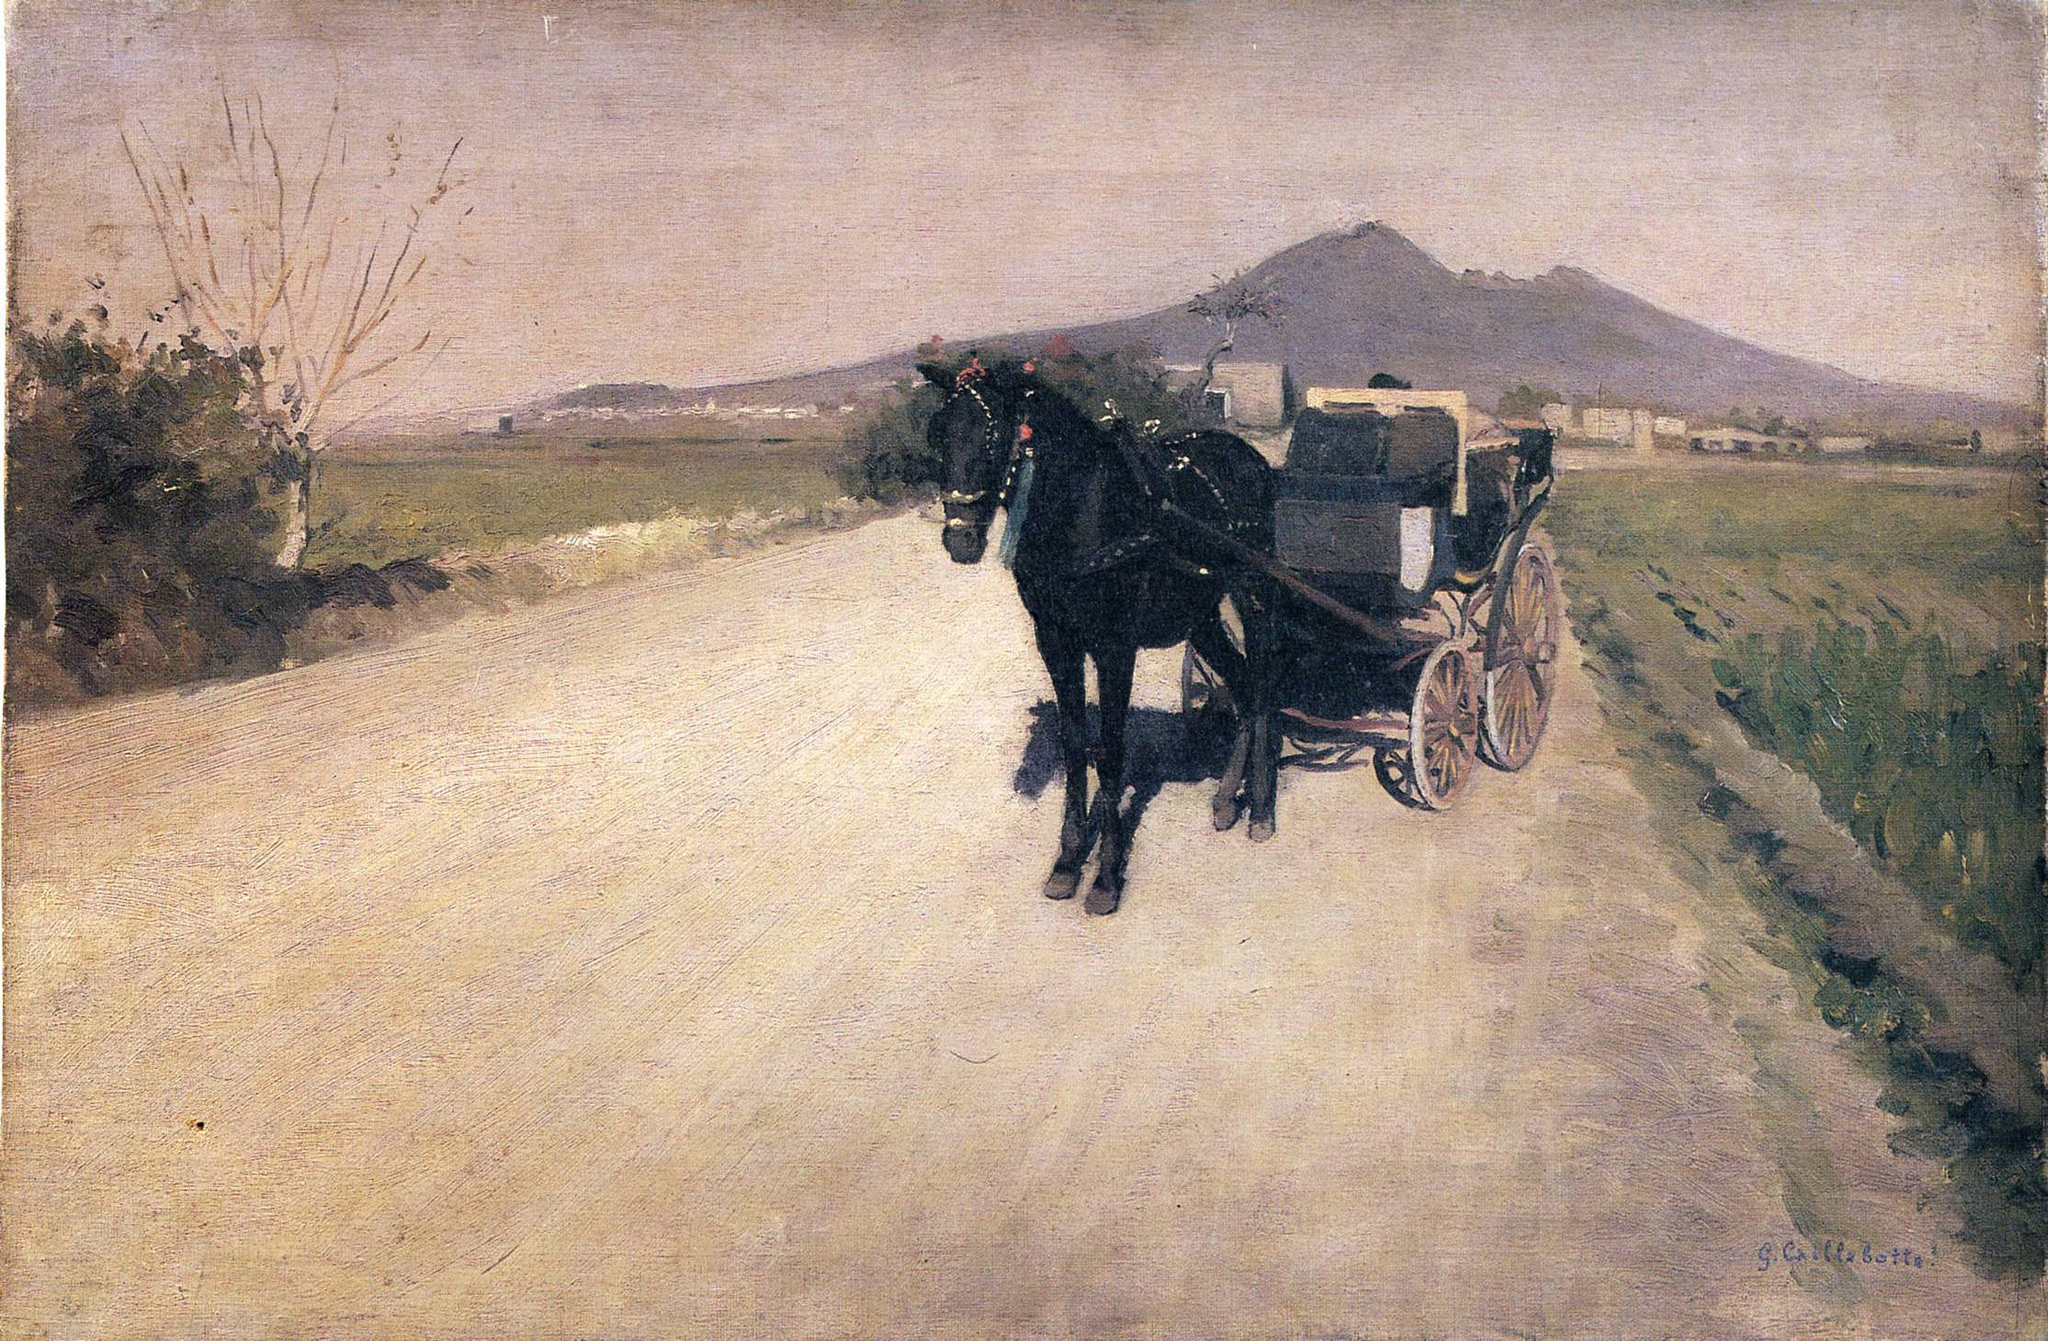How does the artist use light and shade in this painting? The artist masterfully utilizes light and shadow to bring depth and realism into the scene. The sunlight appears to illuminate the road and the side of the carriage, casting subtle shadows that enhance the three-dimensional feel of the image. The contrast between the brightly lit road and the dimly lit horse and carriage emphasizes the main subjects, thus guiding the viewer's focus adeptly through the painting. 